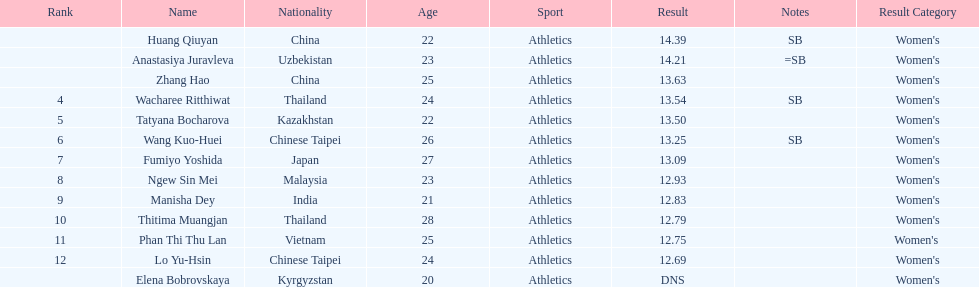How many athletes were from china? 2. 